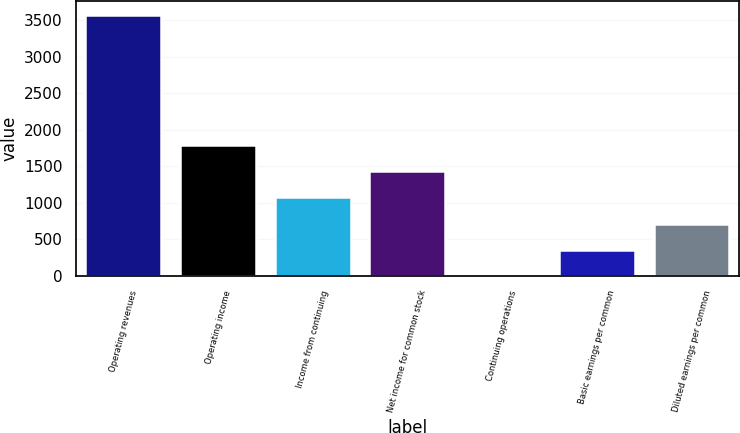Convert chart. <chart><loc_0><loc_0><loc_500><loc_500><bar_chart><fcel>Operating revenues<fcel>Operating income<fcel>Income from continuing<fcel>Net income for common stock<fcel>Continuing operations<fcel>Basic earnings per common<fcel>Diluted earnings per common<nl><fcel>3577<fcel>1789.05<fcel>1073.87<fcel>1431.46<fcel>1.1<fcel>358.69<fcel>716.28<nl></chart> 